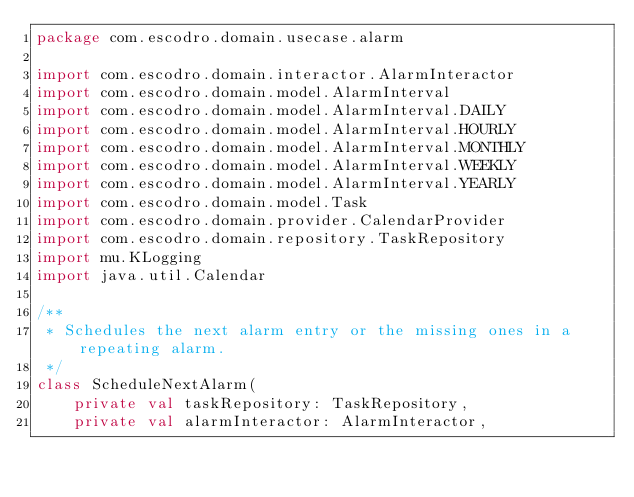<code> <loc_0><loc_0><loc_500><loc_500><_Kotlin_>package com.escodro.domain.usecase.alarm

import com.escodro.domain.interactor.AlarmInteractor
import com.escodro.domain.model.AlarmInterval
import com.escodro.domain.model.AlarmInterval.DAILY
import com.escodro.domain.model.AlarmInterval.HOURLY
import com.escodro.domain.model.AlarmInterval.MONTHLY
import com.escodro.domain.model.AlarmInterval.WEEKLY
import com.escodro.domain.model.AlarmInterval.YEARLY
import com.escodro.domain.model.Task
import com.escodro.domain.provider.CalendarProvider
import com.escodro.domain.repository.TaskRepository
import mu.KLogging
import java.util.Calendar

/**
 * Schedules the next alarm entry or the missing ones in a repeating alarm.
 */
class ScheduleNextAlarm(
    private val taskRepository: TaskRepository,
    private val alarmInteractor: AlarmInteractor,</code> 